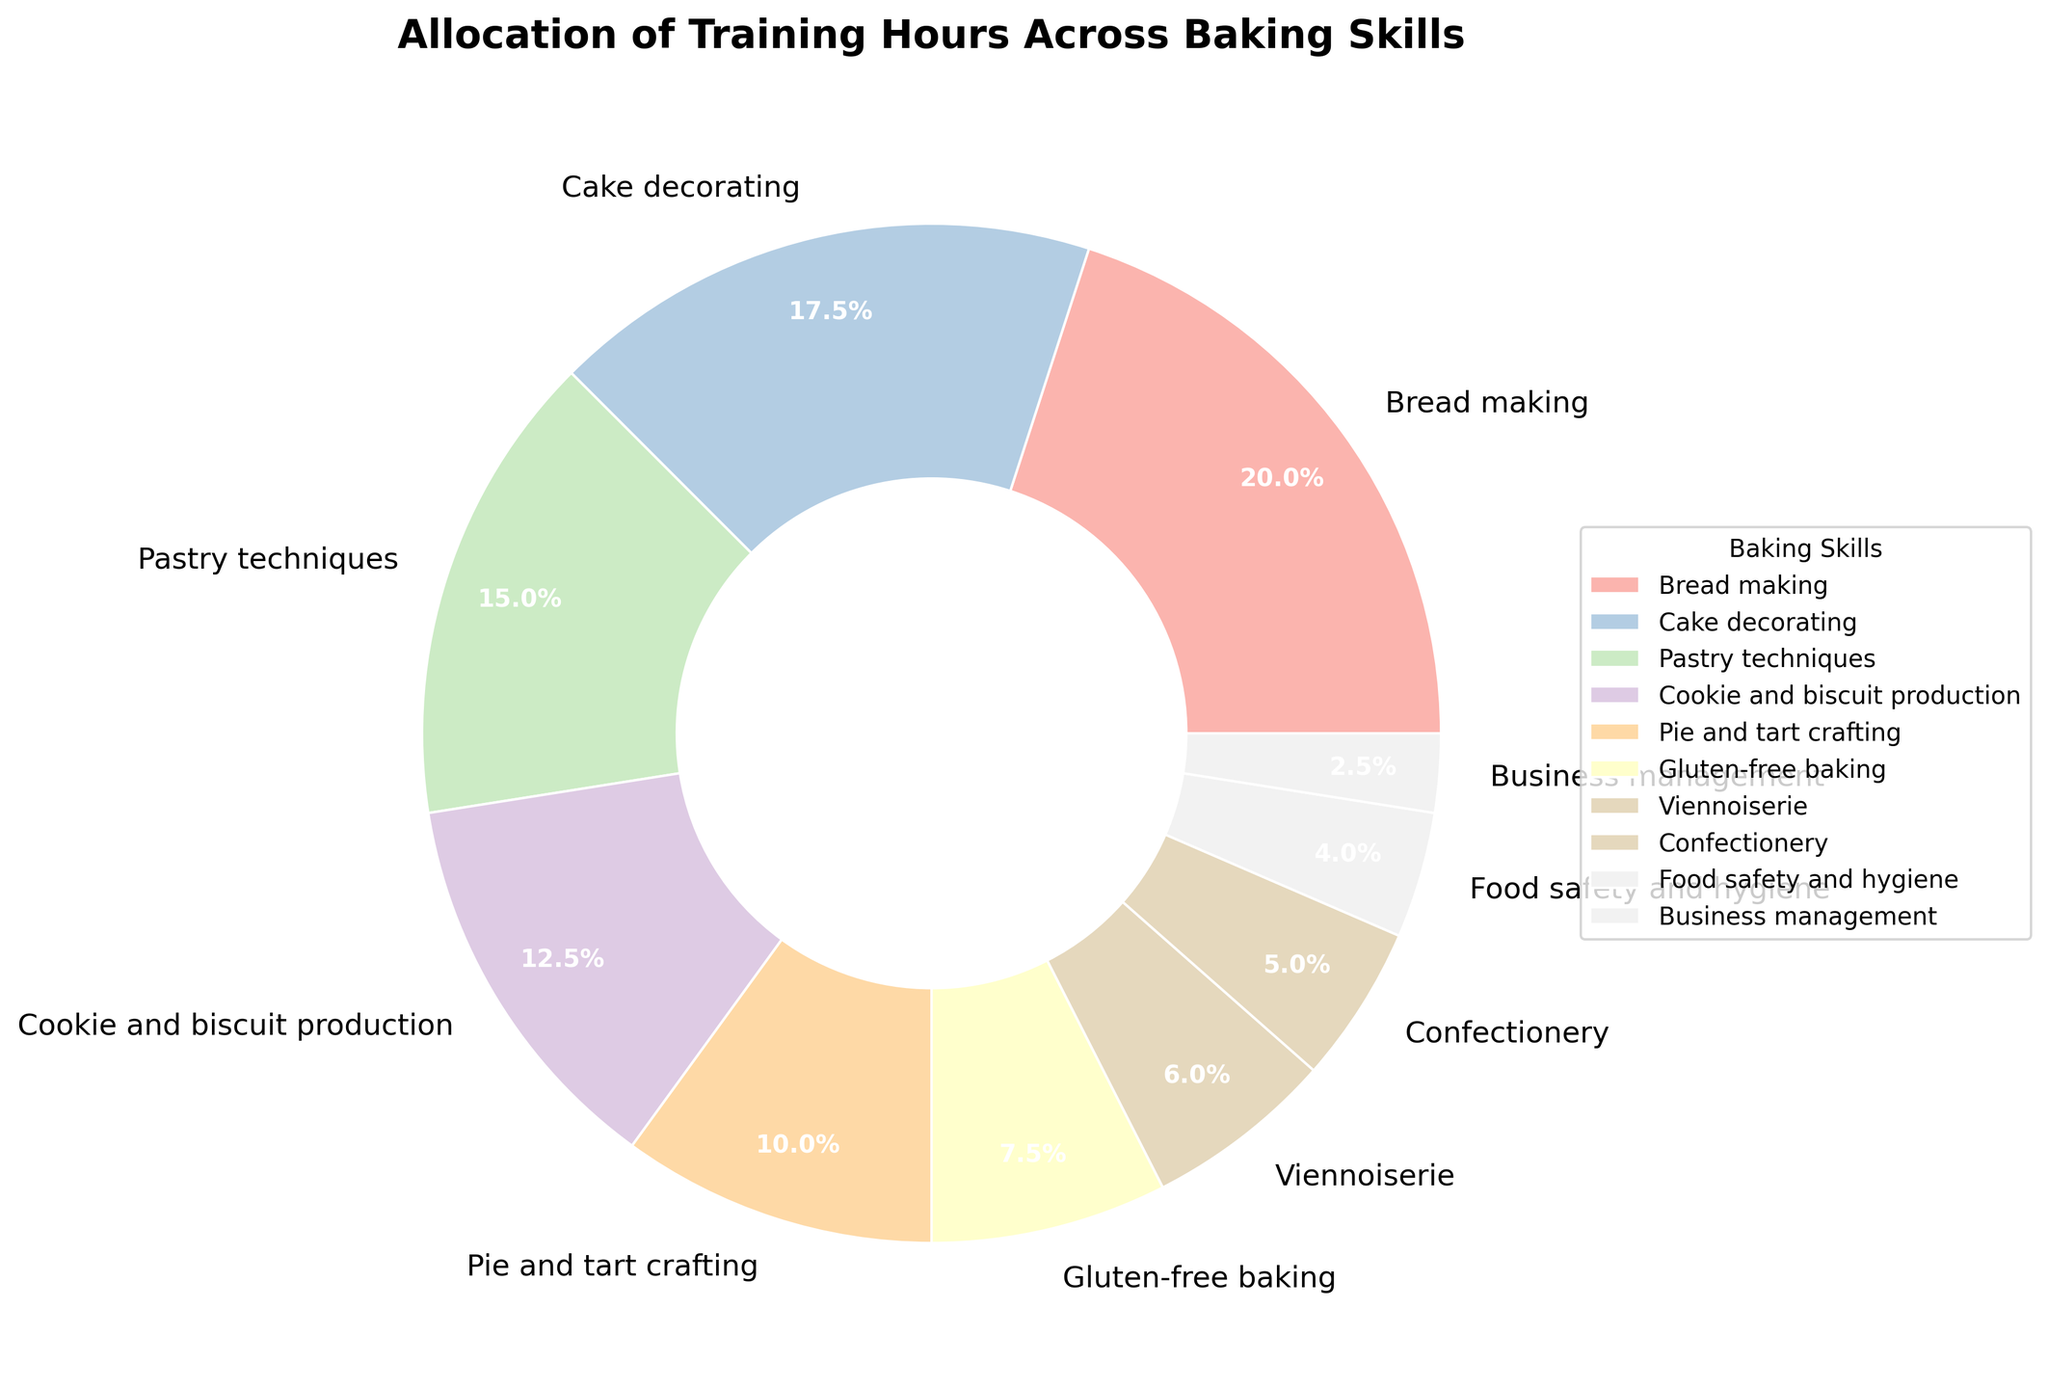What's the dominant skill in terms of training hours? The dominant skill in terms of training hours will have the largest section in the pie chart. Looking at the pie chart, "Bread making" occupies the largest slice.
Answer: Bread making Which skill takes up a smaller percentage of training hours, Pastry techniques or Cookie and biscuit production? To compare, observe the sections of the pie chart labeled "Pastry techniques" and "Cookie and biscuit production". By comparing the slices, "Pastry techniques" takes up a larger percentage than "Cookie and biscuit production".
Answer: Cookie and biscuit production What is the combined percentage of training hours allocated to Bread making and Cake decorating? To find the combined percentage, sum the percentages for "Bread making" (27.0%) and "Cake decorating" (23.6%). 27.0% + 23.6% = 50.6%.
Answer: 50.6% How does the training allocation for Business management compare to Food safety and hygiene? Compare the sizes of the pie chart sections for "Business management" and "Food safety and hygiene". The "Food safety and hygiene" section is larger than "Business management".
Answer: Food safety and hygiene is larger Which skill occupies the smallest portion of the pie chart? The smallest portion of the pie chart will have the smallest slice. Upon examination, "Business management" occupies the smallest slice.
Answer: Business management Are the training hours for Confectionery more or less than those for Viennoiserie? Observe the size of the pie chart sections for "Confectionery" and "Viennoiserie". The slice for "Confectionery" is smaller than that for "Viennoiserie", indicating fewer hours.
Answer: Less What is the approximate percentage of training hours allocated to skills other than Bread making and Cake decorating? First, sum the percentages for "Bread making" (27.0%) and "Cake decorating" (23.6%), which equals 50.6%. Then subtract this from 100% to find the remaining percentage: 100% - 50.6% = 49.4%.
Answer: 49.4% How many times more training hours does Bread making receive compared to Business management? First, find the training hours for "Bread making" (40 hours) and "Business management" (5 hours). Then, divide the Bread making hours by the Business management hours: 40 / 5 = 8.
Answer: 8 times Which skill category, Pastry techniques or Gluten-free baking, receives more training hours, and by how much? Compare the pie chart percentages for "Pastry techniques" (20.3%) and "Gluten-free baking" (10.1%). "Pastry techniques" receives more hours. Calculate the difference: 20.3% - 10.1% = 10.2%.
Answer: Pastry techniques, by 10.2% 